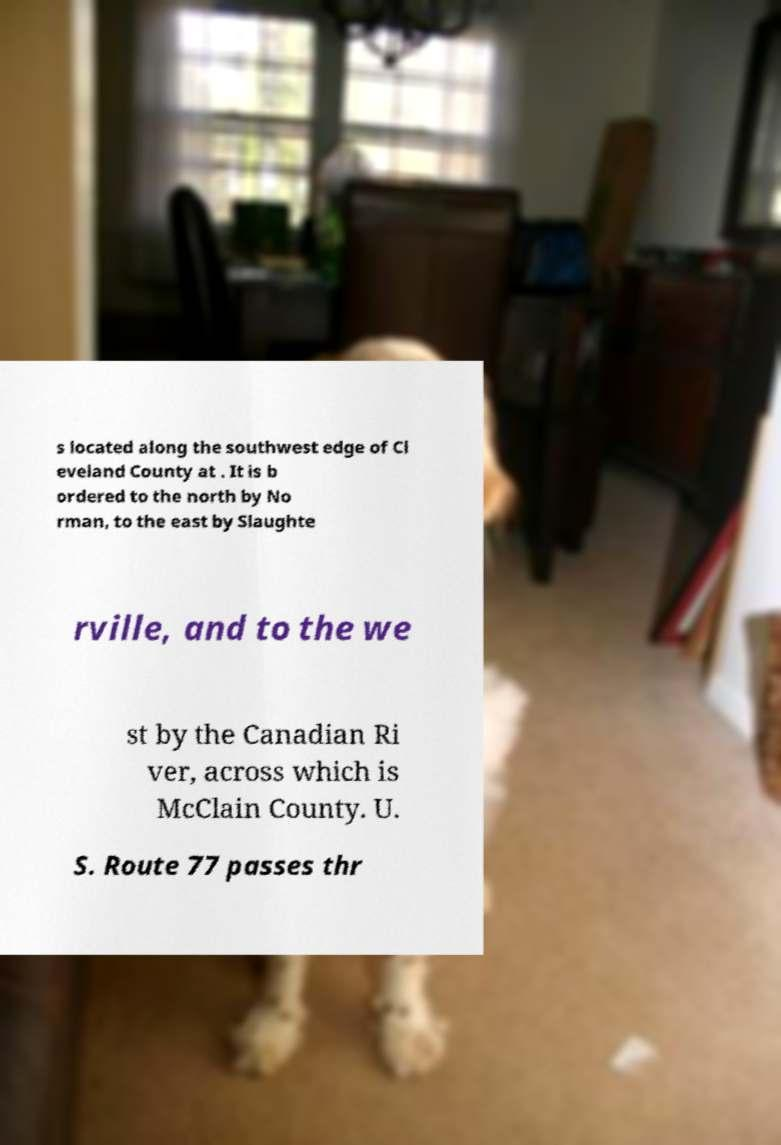Please read and relay the text visible in this image. What does it say? s located along the southwest edge of Cl eveland County at . It is b ordered to the north by No rman, to the east by Slaughte rville, and to the we st by the Canadian Ri ver, across which is McClain County. U. S. Route 77 passes thr 